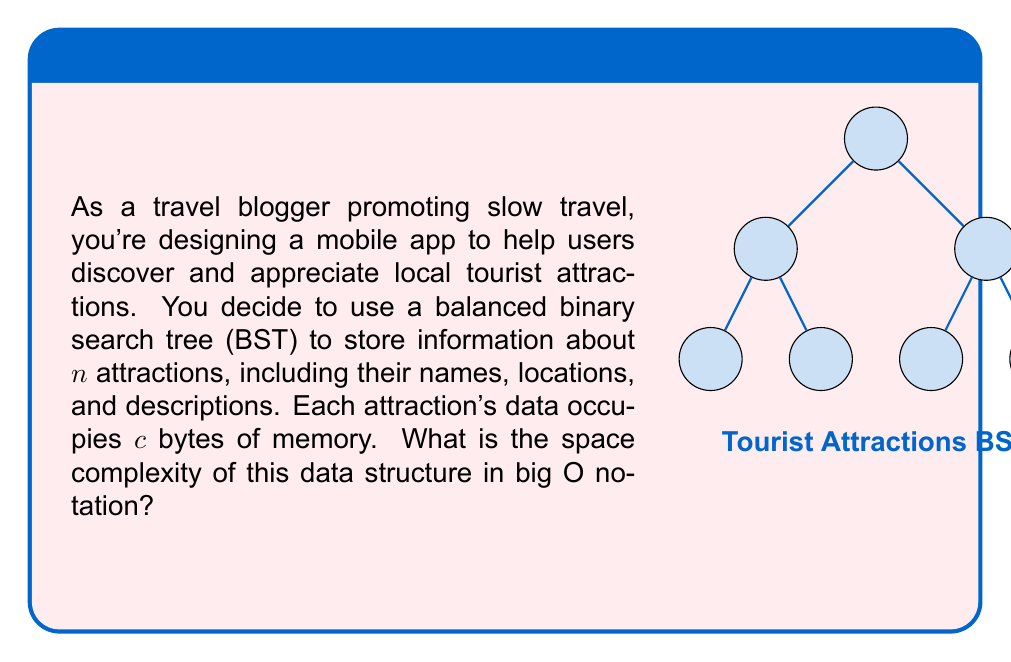Solve this math problem. To determine the space complexity, let's analyze the structure step-by-step:

1) Each node in the BST represents one tourist attraction and contains:
   - Name
   - Location
   - Description
   - Two pointers (left and right child)

2) The total space occupied by each node is $c$ bytes (given in the question) plus the space for two pointers.

3) In a balanced BST, the height of the tree is logarithmic in the number of nodes. However, this doesn't affect the space complexity directly.

4) The total number of nodes in the tree is $n$, where $n$ is the number of attractions.

5) Therefore, the total space used by the BST is:
   $$S(n) = n \cdot (c + 2p)$$
   where $p$ is the size of a pointer.

6) The term $(c + 2p)$ is a constant, let's call it $k$. So we have:
   $$S(n) = n \cdot k = kn$$

7) In big O notation, we drop constant factors. Thus, the space complexity is $O(n)$.

This linear space complexity means that the memory usage grows proportionally with the number of attractions, which is efficient for storing and retrieving information about tourist spots, allowing your slow travel app to scale well with increasing data.
Answer: $O(n)$ 